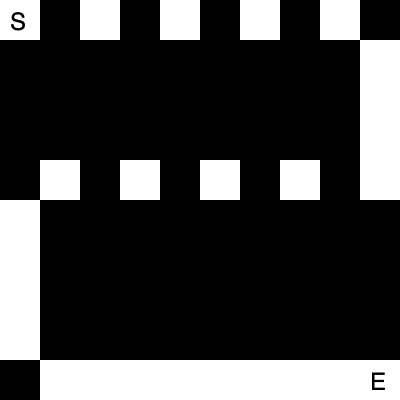In this 8-bit dungeon layout, what is the minimum number of turns required to navigate from the start (S) to the end (E)? To solve this problem, we need to analyze the path from S to E:

1. The dungeon is a 10x10 grid of 40x40 pixel squares.
2. White squares represent walkable paths, while black squares are walls.
3. We start at the top-left corner (S) and need to reach the bottom-right corner (E).
4. A turn is defined as a change in direction (horizontal to vertical or vice versa).

Let's trace the path:
1. Move right from S: 5 squares (no turns yet)
2. Turn and move down: 4 squares (1 turn)
3. Turn and move left: 4 squares (2 turns)
4. Turn and move down: 4 squares (3 turns)
5. Turn and move right: 5 squares to reach E (4 turns)

The path follows an inverted 'U' shape, requiring 4 turns in total to navigate from S to E.
Answer: 4 turns 